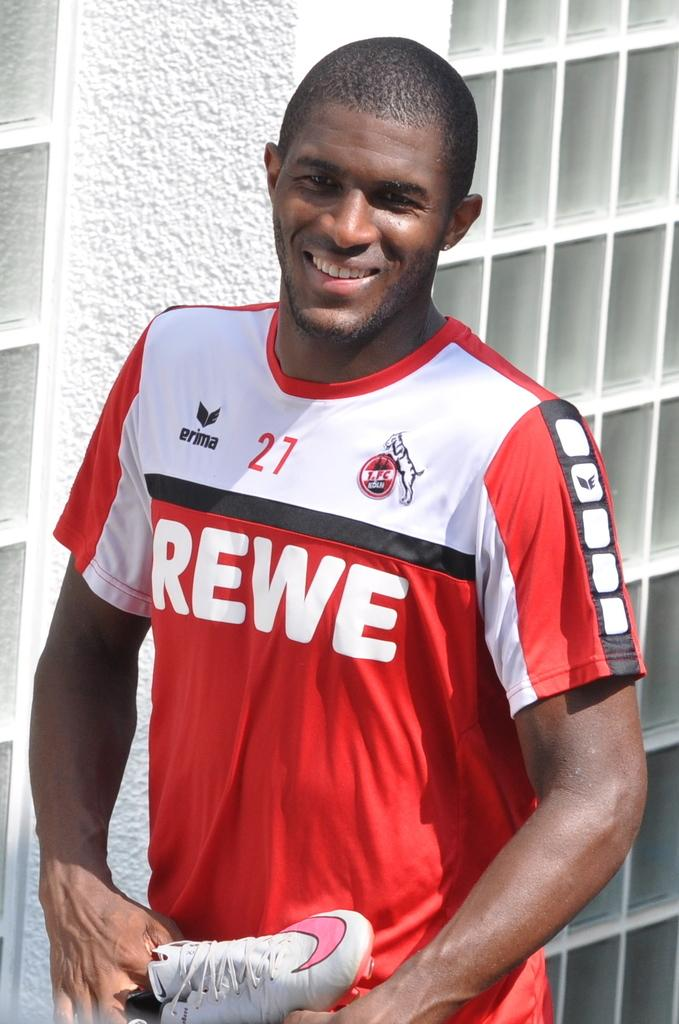<image>
Relay a brief, clear account of the picture shown. Man with a rewe jersey standing and posing for a picture 